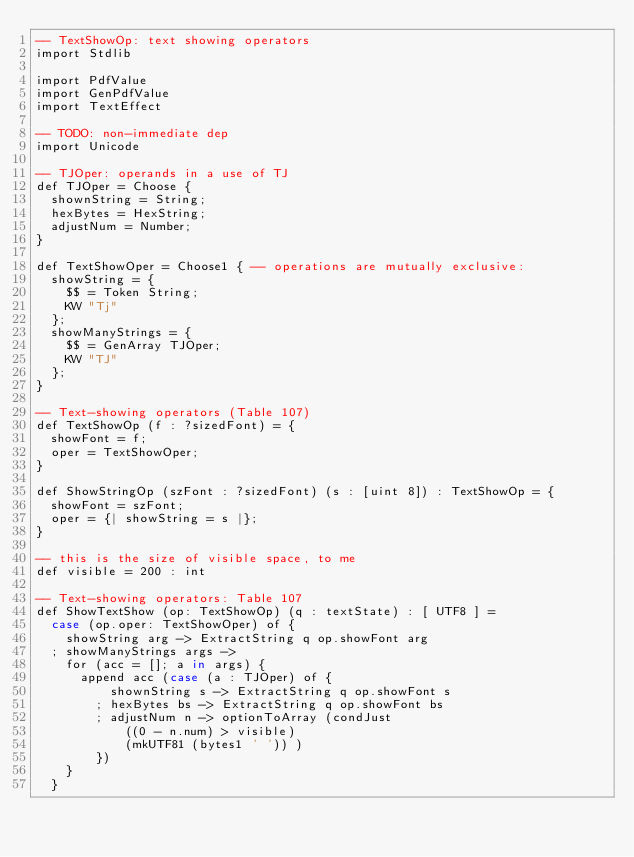Convert code to text. <code><loc_0><loc_0><loc_500><loc_500><_SQL_>-- TextShowOp: text showing operators
import Stdlib

import PdfValue
import GenPdfValue
import TextEffect

-- TODO: non-immediate dep
import Unicode

-- TJOper: operands in a use of TJ
def TJOper = Choose {
  shownString = String;
  hexBytes = HexString;
  adjustNum = Number;
}

def TextShowOper = Choose1 { -- operations are mutually exclusive:
  showString = {
    $$ = Token String;
    KW "Tj" 
  };
  showManyStrings = {
    $$ = GenArray TJOper;
    KW "TJ"
  };
}

-- Text-showing operators (Table 107)
def TextShowOp (f : ?sizedFont) = {
  showFont = f;
  oper = TextShowOper;
}

def ShowStringOp (szFont : ?sizedFont) (s : [uint 8]) : TextShowOp = {
  showFont = szFont;
  oper = {| showString = s |};
}

-- this is the size of visible space, to me
def visible = 200 : int

-- Text-showing operators: Table 107
def ShowTextShow (op: TextShowOp) (q : textState) : [ UTF8 ] =
  case (op.oper: TextShowOper) of {
    showString arg -> ExtractString q op.showFont arg
  ; showManyStrings args ->
    for (acc = []; a in args) {
      append acc (case (a : TJOper) of {
          shownString s -> ExtractString q op.showFont s
        ; hexBytes bs -> ExtractString q op.showFont bs
        ; adjustNum n -> optionToArray (condJust
            ((0 - n.num) > visible)
            (mkUTF81 (bytes1 ' ')) )
        })
    }
  }
</code> 